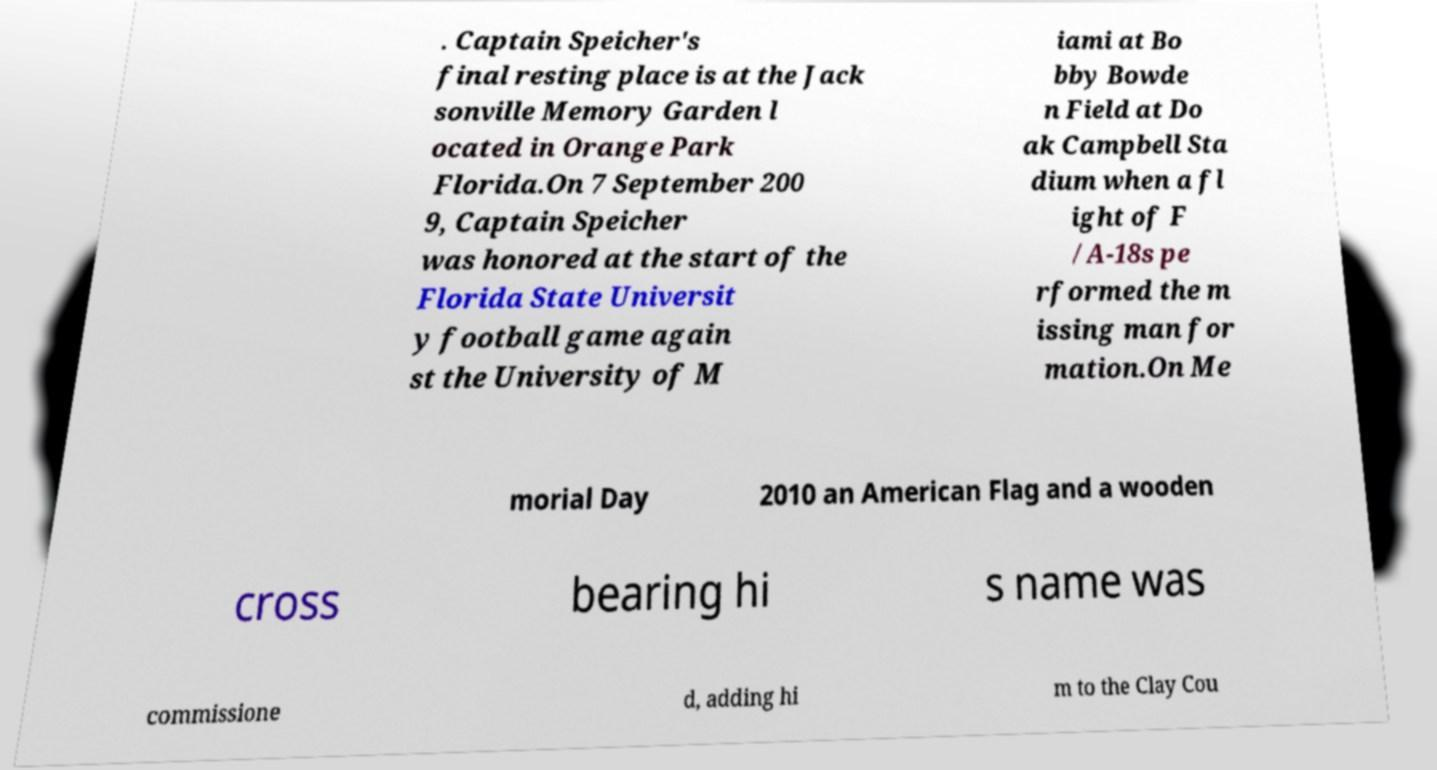What messages or text are displayed in this image? I need them in a readable, typed format. . Captain Speicher's final resting place is at the Jack sonville Memory Garden l ocated in Orange Park Florida.On 7 September 200 9, Captain Speicher was honored at the start of the Florida State Universit y football game again st the University of M iami at Bo bby Bowde n Field at Do ak Campbell Sta dium when a fl ight of F /A-18s pe rformed the m issing man for mation.On Me morial Day 2010 an American Flag and a wooden cross bearing hi s name was commissione d, adding hi m to the Clay Cou 